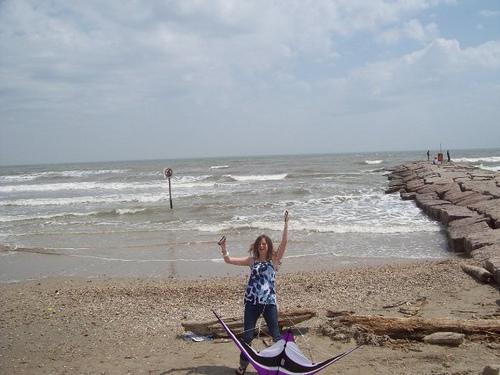Is she going to fly a kite?
Answer briefly. Yes. Does she shave her armpits?
Quick response, please. Yes. How many footsteps are in the sand?
Quick response, please. 0. How many people are in the picture?
Short answer required. 1. 